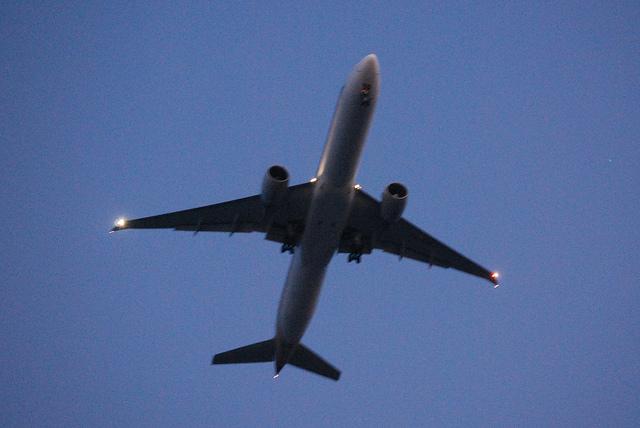Is this a military aircraft?
Be succinct. No. What is reflecting off the plane?
Be succinct. Lights. Is the landing gear up or down?
Write a very short answer. Up. Is the landing gear up?
Give a very brief answer. Yes. What color is the underbelly of the plane?
Be succinct. White. How many different colors is this airplane?
Keep it brief. 1. Is the  plane flying?
Be succinct. Yes. How many engines does this craft have?
Give a very brief answer. 2. Does this picture show bad weather?
Concise answer only. No. 